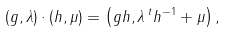Convert formula to latex. <formula><loc_0><loc_0><loc_500><loc_500>( g , \lambda ) \cdot ( h , \mu ) = \left ( g h , \lambda \, ^ { t } h ^ { - 1 } + \mu \right ) ,</formula> 